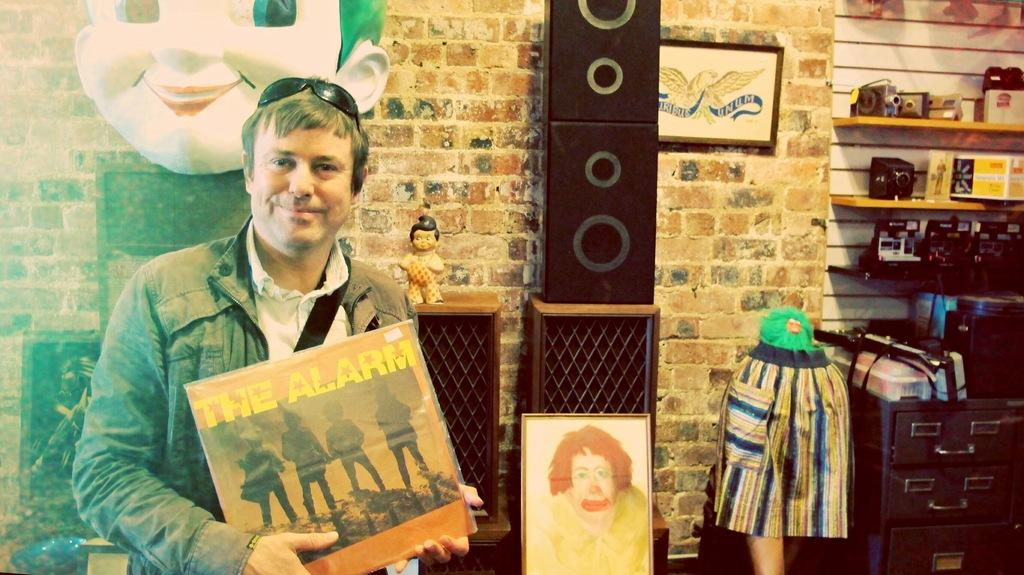What is the man holding in the image? The man is holding a book. What can be seen in the image besides the man and the book? There are speakers, toys, pictures on the wall, a camera in a rock, and objects above the cupboard visible in the image. What type of friction can be seen between the man's skin and the book in the image? There is no indication of friction between the man's skin and the book in the image. The man is simply holding the book, and there is no information about the texture or interaction between the two objects. 